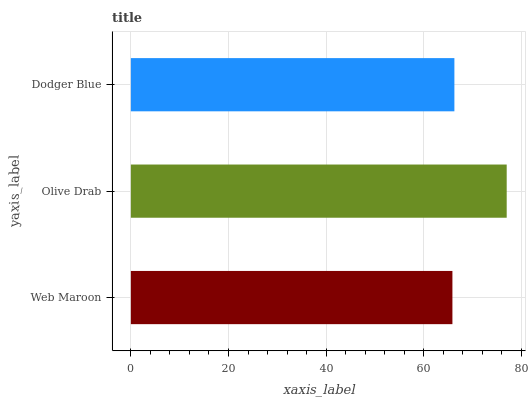Is Web Maroon the minimum?
Answer yes or no. Yes. Is Olive Drab the maximum?
Answer yes or no. Yes. Is Dodger Blue the minimum?
Answer yes or no. No. Is Dodger Blue the maximum?
Answer yes or no. No. Is Olive Drab greater than Dodger Blue?
Answer yes or no. Yes. Is Dodger Blue less than Olive Drab?
Answer yes or no. Yes. Is Dodger Blue greater than Olive Drab?
Answer yes or no. No. Is Olive Drab less than Dodger Blue?
Answer yes or no. No. Is Dodger Blue the high median?
Answer yes or no. Yes. Is Dodger Blue the low median?
Answer yes or no. Yes. Is Web Maroon the high median?
Answer yes or no. No. Is Olive Drab the low median?
Answer yes or no. No. 